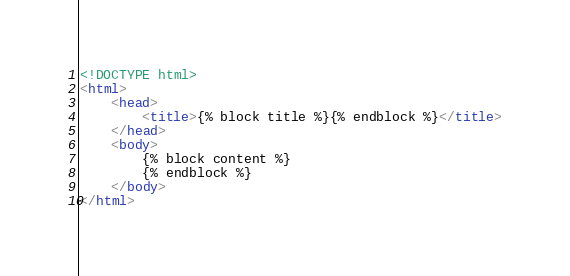<code> <loc_0><loc_0><loc_500><loc_500><_HTML_><!DOCTYPE html>
<html>
	<head>
		<title>{% block title %}{% endblock %}</title>
	</head>
	<body>
		{% block content %}
		{% endblock %}
	</body>
</html>
</code> 